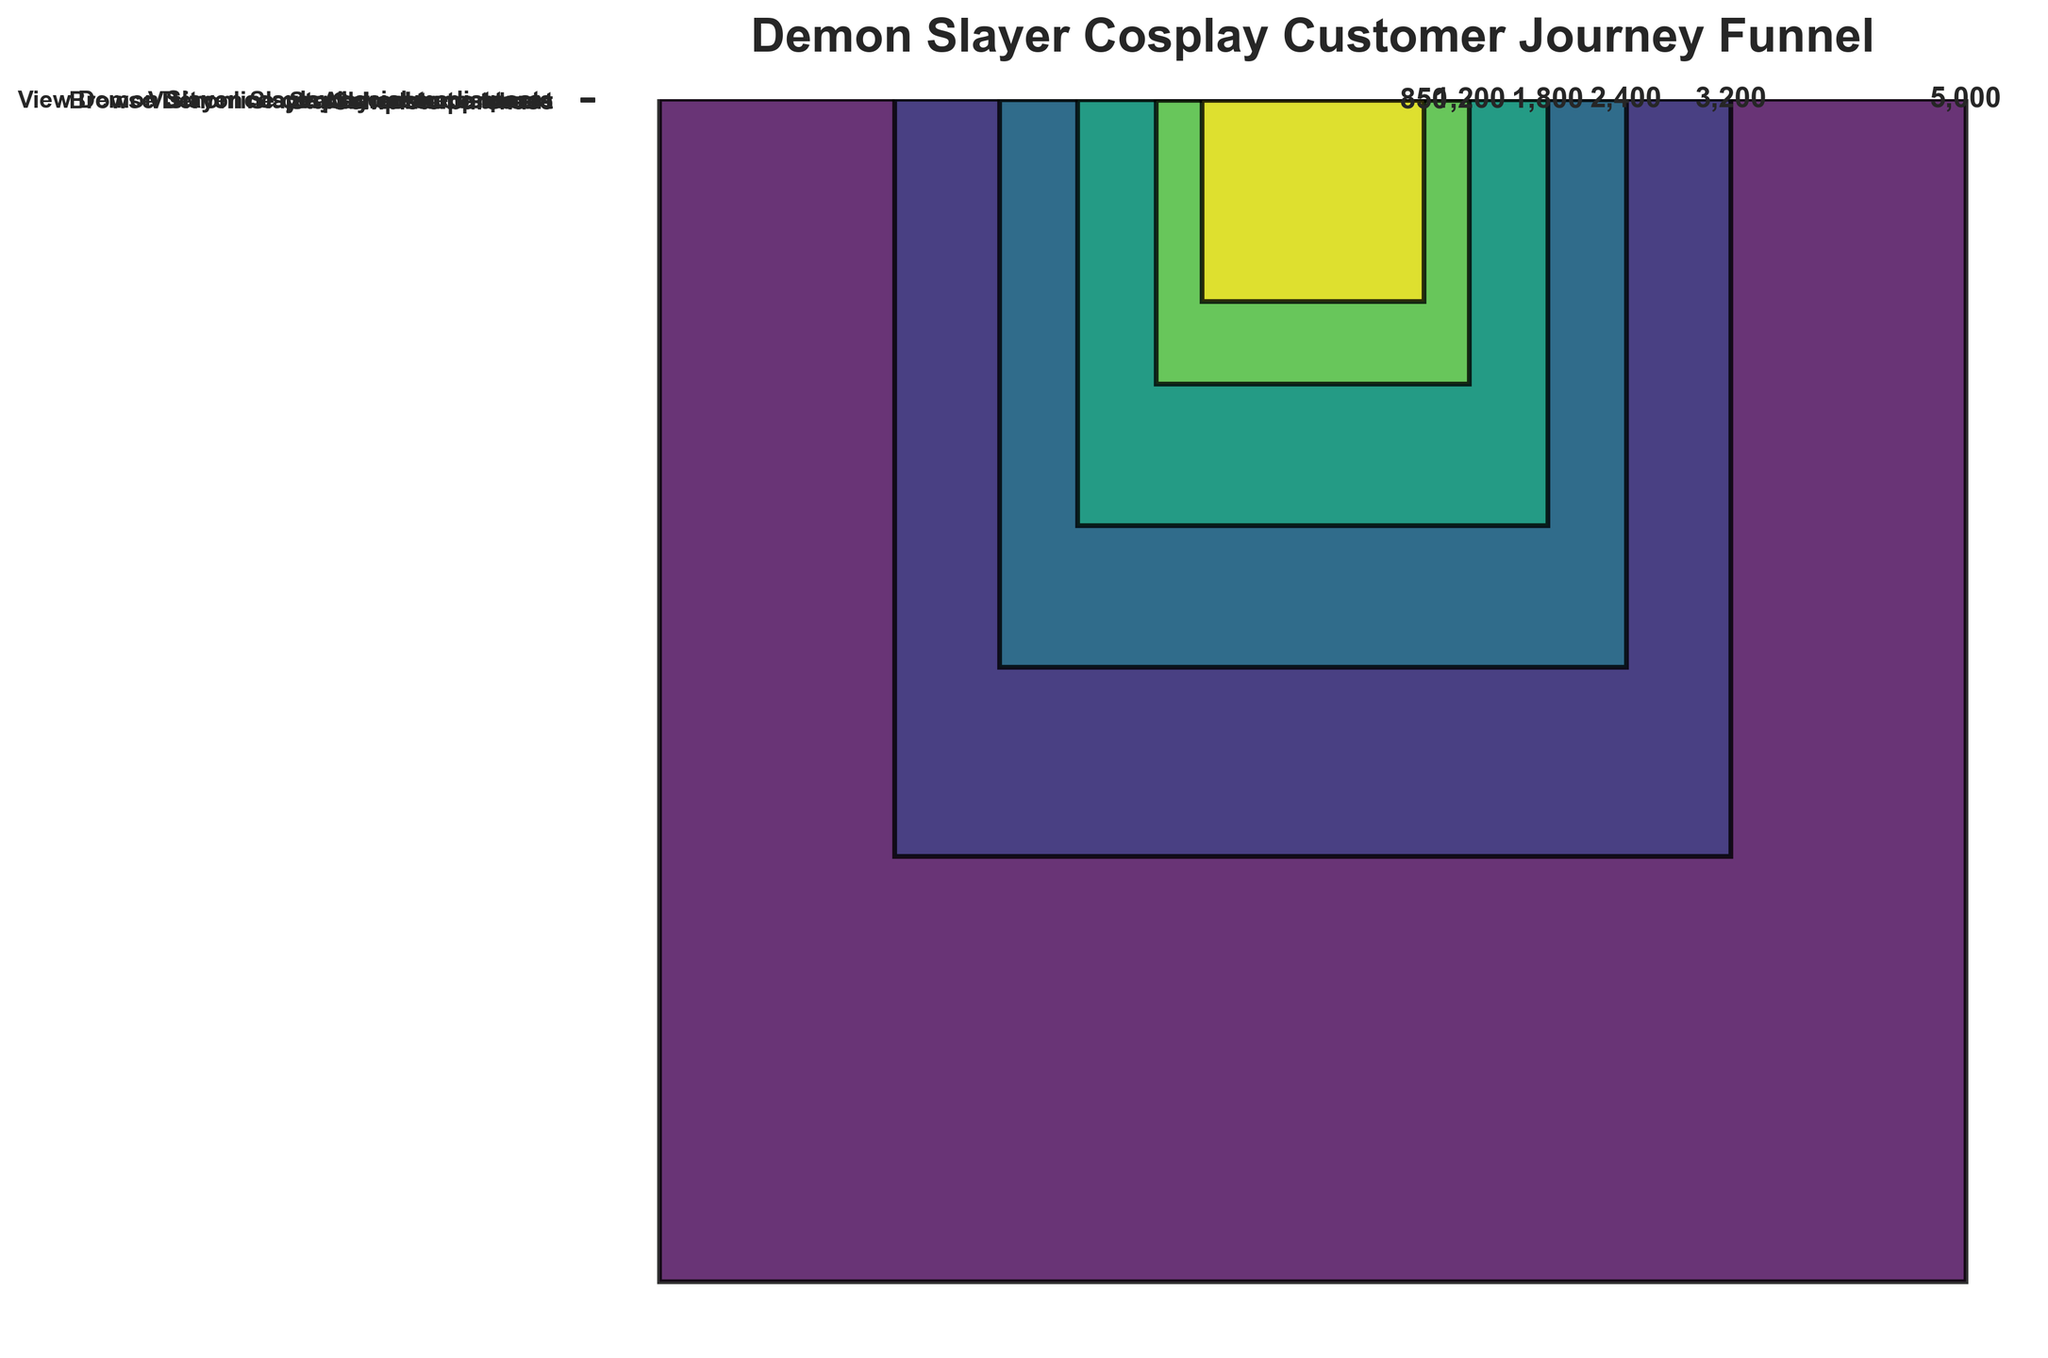What is the title of the figure? The title is located at the top of the figure and is displayed prominently in a larger font size.
Answer: Demon Slayer Cosplay Customer Journey Funnel How many stages are there in the customer journey? The number of stages can be determined by counting the distinct stages listed along the y-axis of the funnel chart.
Answer: 6 Which stage has the highest count? The highest count can be found by identifying the widest bar in the funnel chart, which represents the stage with the most customers.
Answer: View Demon Slayer cosplay social media posts What is the drop-off from the stage "Browse Demon Slayer character costumes" to "Add costume to cart"? The drop-off can be calculated by subtracting the count of the latter stage from the count of the former stage.
Answer: 600 What is the total number of customers from the initial interest to the final purchase completion? The total number is the count at the initial stage since it represents the widest part of the funnel.
Answer: 5000 What percentage of customers who start the checkout process complete the purchase? The percentage can be calculated by dividing the number who completed the purchase by those who started the checkout process and multiplying by 100.
Answer: 70.83% How does the number of customers who add a costume to the cart compare to those who complete the purchase? The comparison can be made by looking at the counts for each stage and determining which is larger or by how much.
Answer: 950 more customers added costumes to the cart than those who completed the purchase Which stage experiences the greatest drop-off in customer count? The greatest drop-off is identified by calculating the difference in counts between successive stages and finding the maximum difference.
Answer: Visit online cosplay costume stores to Browse Demon Slayer character costumes Is there a stage where more than half of the customers from the previous stage drop off? If so, which one? This can be determined by examining each pair of successive stages and checking if the count drops by more than 50% from the previous stage.
Answer: No What can be inferred about customer engagement from the initial interest to the final purchase? This inference involves looking at the narrowing funnel shape and relating the progressive drop-offs to customer engagement through the purchasing process.
Answer: Customer engagement decreases significantly from initial interest to purchase completion 